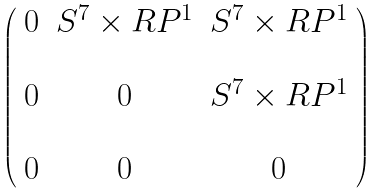<formula> <loc_0><loc_0><loc_500><loc_500>\left ( \begin{array} { c c c } 0 & S ^ { 7 } \times { R } P ^ { 1 } & S ^ { 7 } \times { R } P ^ { 1 } \\ & & \\ 0 & 0 & S ^ { 7 } \times { R } P ^ { 1 } \\ & & \\ 0 & 0 & 0 \end{array} \right )</formula> 